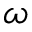Convert formula to latex. <formula><loc_0><loc_0><loc_500><loc_500>\omega</formula> 